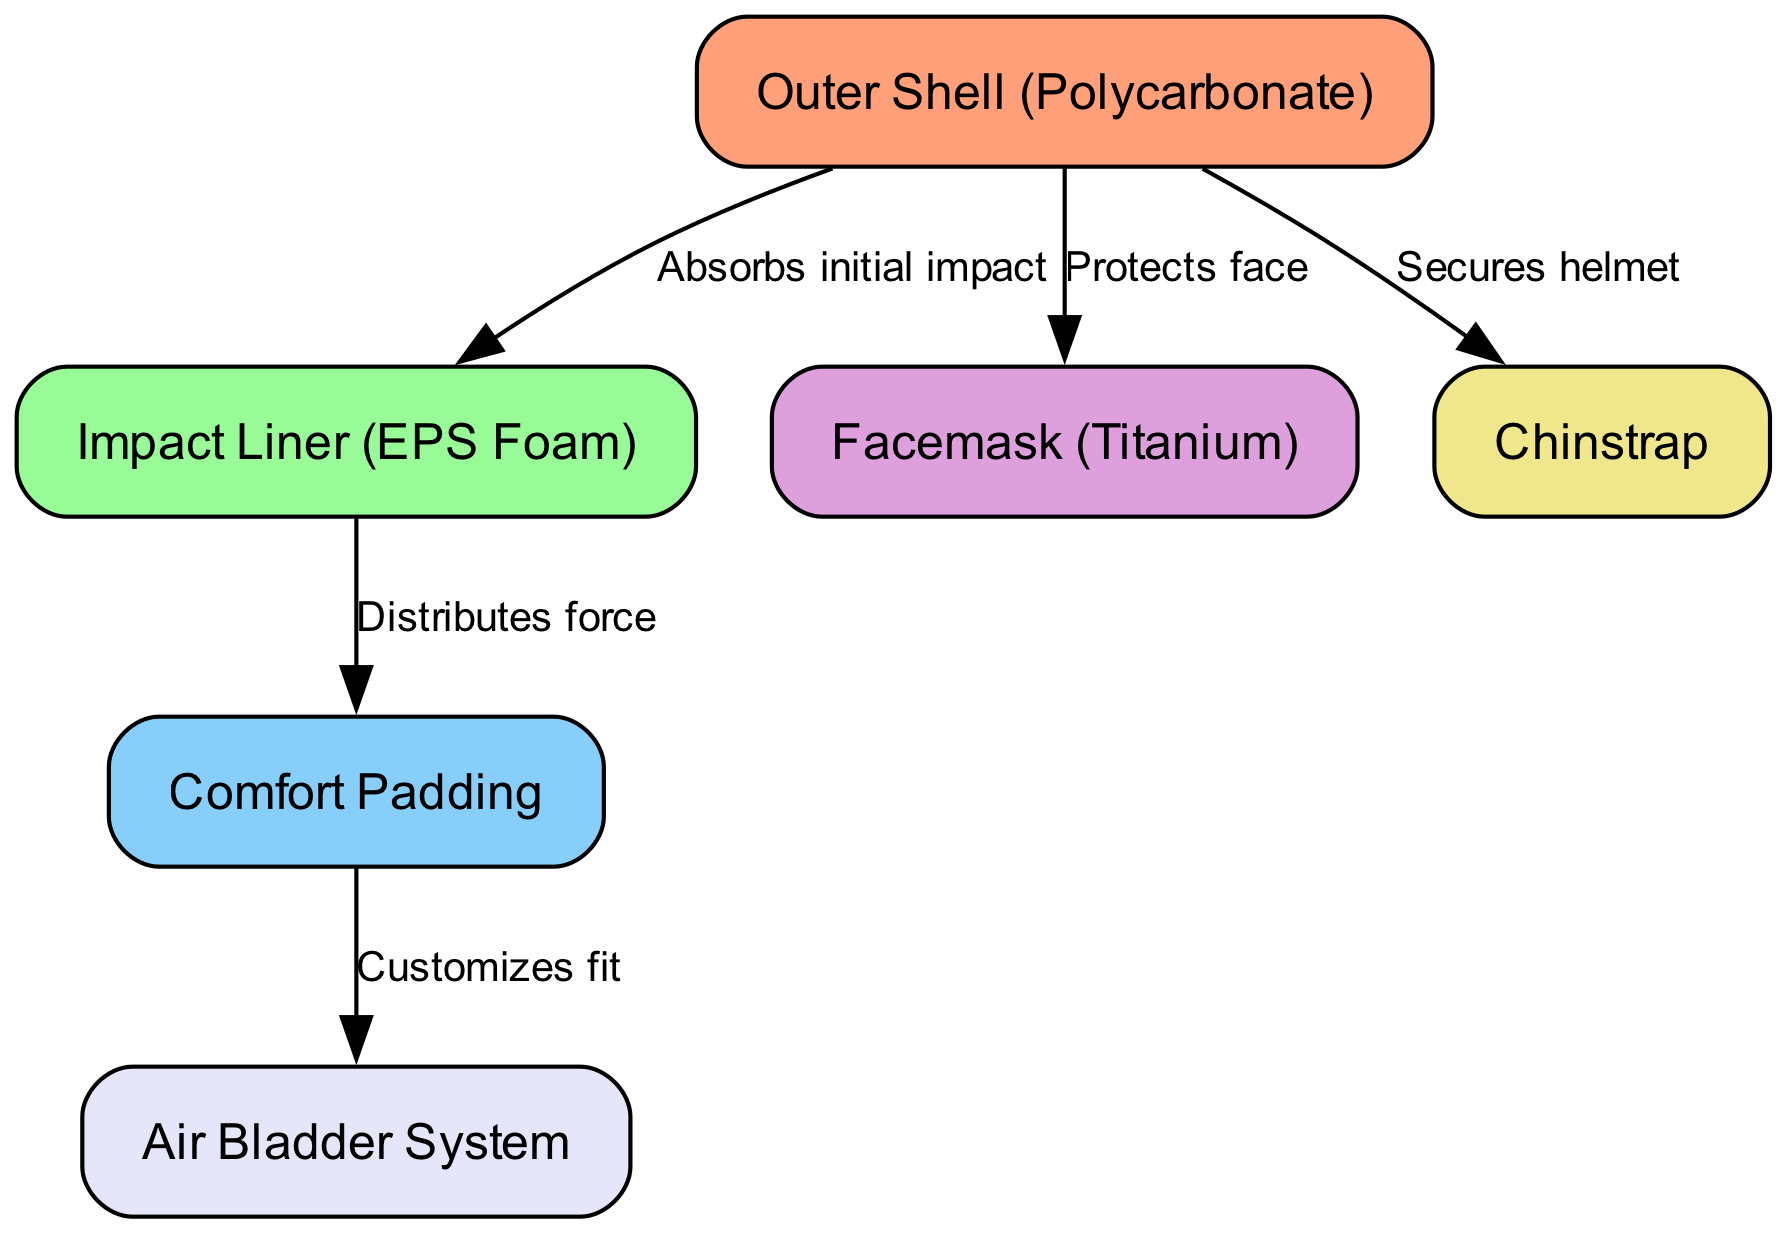What is the material of the outer shell? The outer shell is labeled as "Polycarbonate," which is explicitly stated in the diagram.
Answer: Polycarbonate How many nodes are in the diagram? Counting each node listed shows there are six nodes in total: outer shell, impact liner, comfort padding, facemask, chinstrap, and air bladder system.
Answer: 6 What does the impact liner do? The edge connected to the impact liner indicates that it "Distributes force," which suggests its function in the helmet's safety system.
Answer: Distributes force Which component protects the face? The edge leading from the outer shell to the facemask indicates that the facemask is designed to "Protects face."
Answer: Protects face What connects comfort padding to the air bladder? The edge from the comfort padding to the air bladder shows that it "Customizes fit," indicating their functional relationship.
Answer: Customizes fit What is the function of the chinstrap? The chinstrap is linked to the shell with the label "Secures helmet," directly indicating its purpose in the helmet structure.
Answer: Secures helmet Which component absorbs initial impact? The edge from the shell to the impact liner states that it "Absorbs initial impact," identifying the role of the impact liner in protecting the player.
Answer: Absorbs initial impact What type of padding is found inside the helmet? The diagram specifies "Comfort Padding" as a distinct node, indicating its presence as a type of internal padding.
Answer: Comfort Padding Which material is the facemask made of? The node for facemask is labeled "Titanium," giving its specific material composition according to the diagram.
Answer: Titanium 